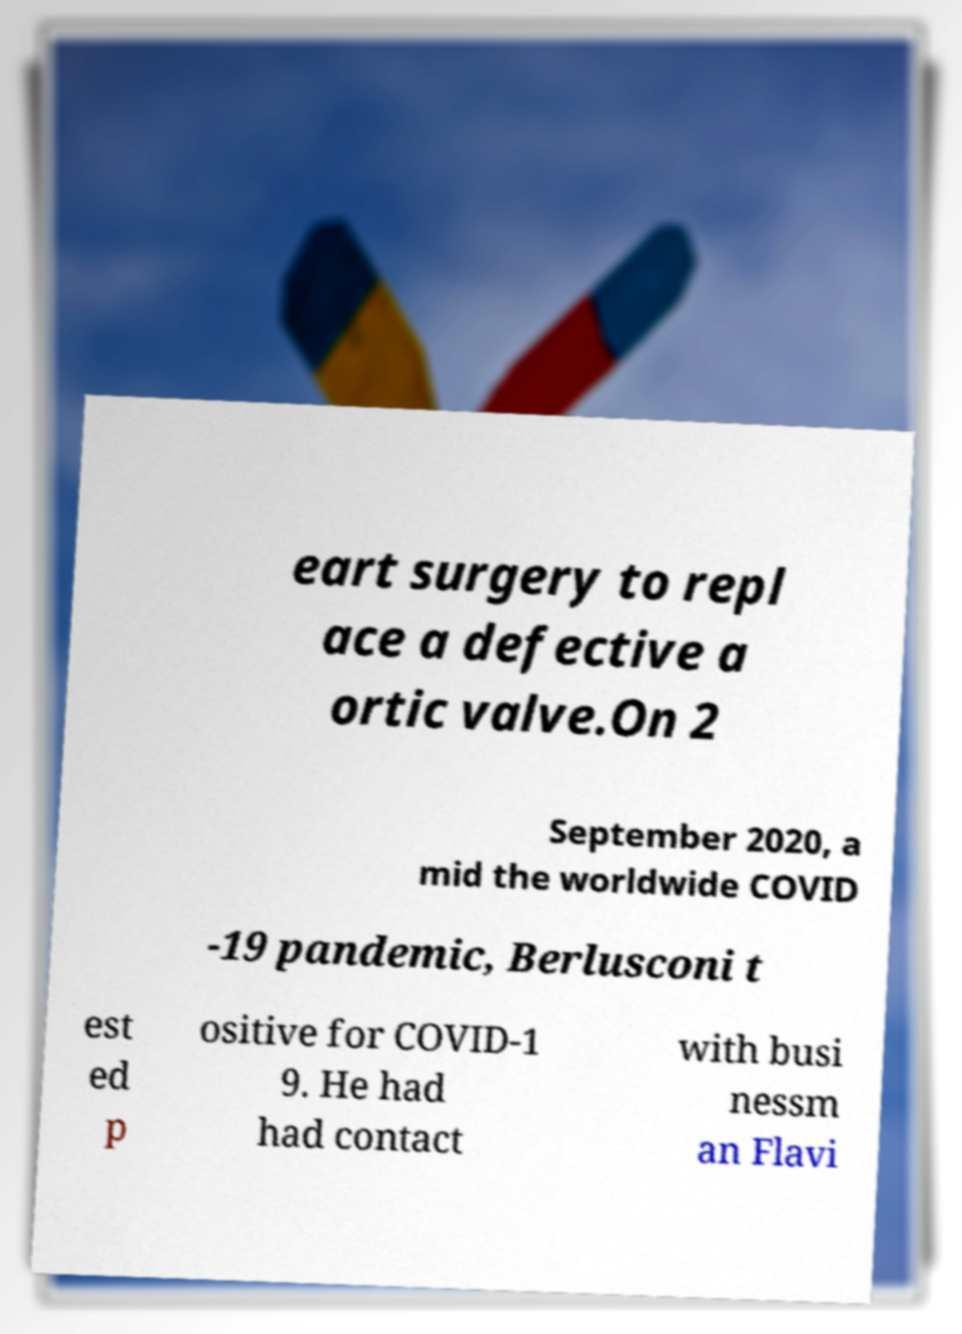Please read and relay the text visible in this image. What does it say? eart surgery to repl ace a defective a ortic valve.On 2 September 2020, a mid the worldwide COVID -19 pandemic, Berlusconi t est ed p ositive for COVID-1 9. He had had contact with busi nessm an Flavi 